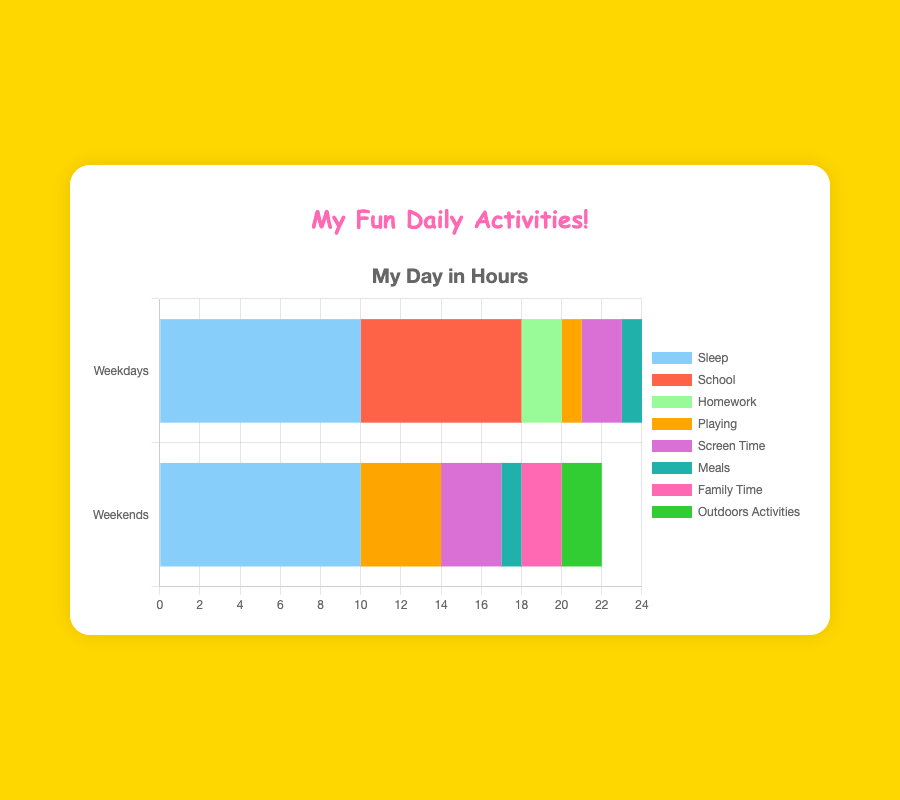What is the total time spent on academia activities during weekdays? For weekdays, the time spent on academia activities includes School (8 hours) and Homework (2 hours). Summing these up, 8 + 2 = 10 hours
Answer: 10 hours Which activity is the longest during weekdays and weekends? On weekdays, the longest activity is Sleep with 10 hours. Similarly, on weekends, the longest activity is also Sleep with 10 hours
Answer: Sleep How much more time is spent on Playing during the weekends compared to weekdays? On weekdays, Playing takes 1 hour. On weekends, it takes 4 hours. The difference is 4 - 1 = 3 hours
Answer: 3 hours What is the combined time for Screen Time and Playing during weekends? During weekends, Screen Time is 3 hours and Playing is 4 hours. Adding them together, 3 + 4 = 7 hours
Answer: 7 hours What activity appears on weekends but not on weekdays? The activities shown in the chart for weekends but not for weekdays are Family Time and Outdoors Activities
Answer: Family Time and Outdoors Activities Compare the time spent on Meals during weekdays and weekends. Which one is more? Meals take 1 hour both during weekdays and weekends. The time spent is equal for both
Answer: Equal Which activity has the same duration in both weekdays and weekends? Sleep and Meals both have the same duration of 10 hours and 1 hour respectively during both weekdays and weekends
Answer: Sleep and Meals Which activity during weekends has a duration closest to the time spent on Sleeping during weekdays? Sleep during weekdays is 10 hours. During weekends, the activity closest in duration is Sleep, which is also 10 hours
Answer: Sleep What is the total time spent on all activities during weekdays? Adding all the hours spent on all activities during weekdays: Sleep (10) + School (8) + Homework (2) + Playing (1) + Screen Time (2) + Meals (1) = 24 hours
Answer: 24 hours How does the time spent on Family Time compare to the time spent on School during weekdays? Family Time is only during weekends with 2 hours. School is only during weekdays with 8 hours. Family Time is less than School
Answer: Family Time is less 